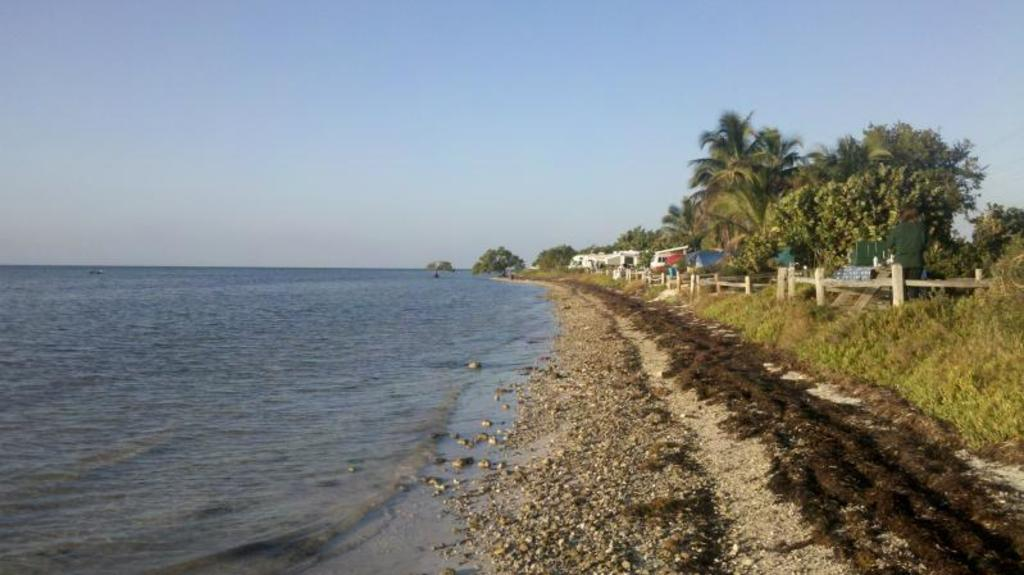What is the primary element visible in the image? There is water in the image. What can be seen in the background of the image? There are plants, trees, and houses in the background of the image. Can you describe the natural elements present in the image? The image features water, plants, and trees. What type of stick can be seen in the water in the image? There is no stick visible in the water in the image. How is the rice being prepared in the image? There is no rice present in the image. 